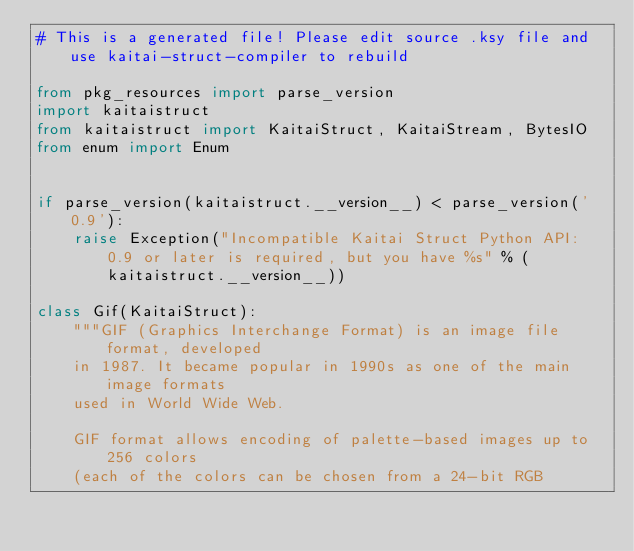Convert code to text. <code><loc_0><loc_0><loc_500><loc_500><_Python_># This is a generated file! Please edit source .ksy file and use kaitai-struct-compiler to rebuild

from pkg_resources import parse_version
import kaitaistruct
from kaitaistruct import KaitaiStruct, KaitaiStream, BytesIO
from enum import Enum


if parse_version(kaitaistruct.__version__) < parse_version('0.9'):
    raise Exception("Incompatible Kaitai Struct Python API: 0.9 or later is required, but you have %s" % (kaitaistruct.__version__))

class Gif(KaitaiStruct):
    """GIF (Graphics Interchange Format) is an image file format, developed
    in 1987. It became popular in 1990s as one of the main image formats
    used in World Wide Web.
    
    GIF format allows encoding of palette-based images up to 256 colors
    (each of the colors can be chosen from a 24-bit RGB</code> 